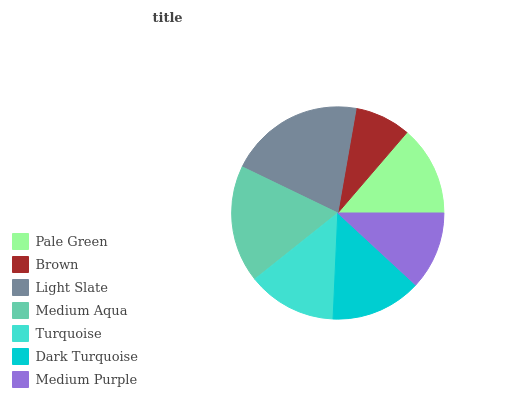Is Brown the minimum?
Answer yes or no. Yes. Is Light Slate the maximum?
Answer yes or no. Yes. Is Light Slate the minimum?
Answer yes or no. No. Is Brown the maximum?
Answer yes or no. No. Is Light Slate greater than Brown?
Answer yes or no. Yes. Is Brown less than Light Slate?
Answer yes or no. Yes. Is Brown greater than Light Slate?
Answer yes or no. No. Is Light Slate less than Brown?
Answer yes or no. No. Is Pale Green the high median?
Answer yes or no. Yes. Is Pale Green the low median?
Answer yes or no. Yes. Is Medium Aqua the high median?
Answer yes or no. No. Is Medium Purple the low median?
Answer yes or no. No. 